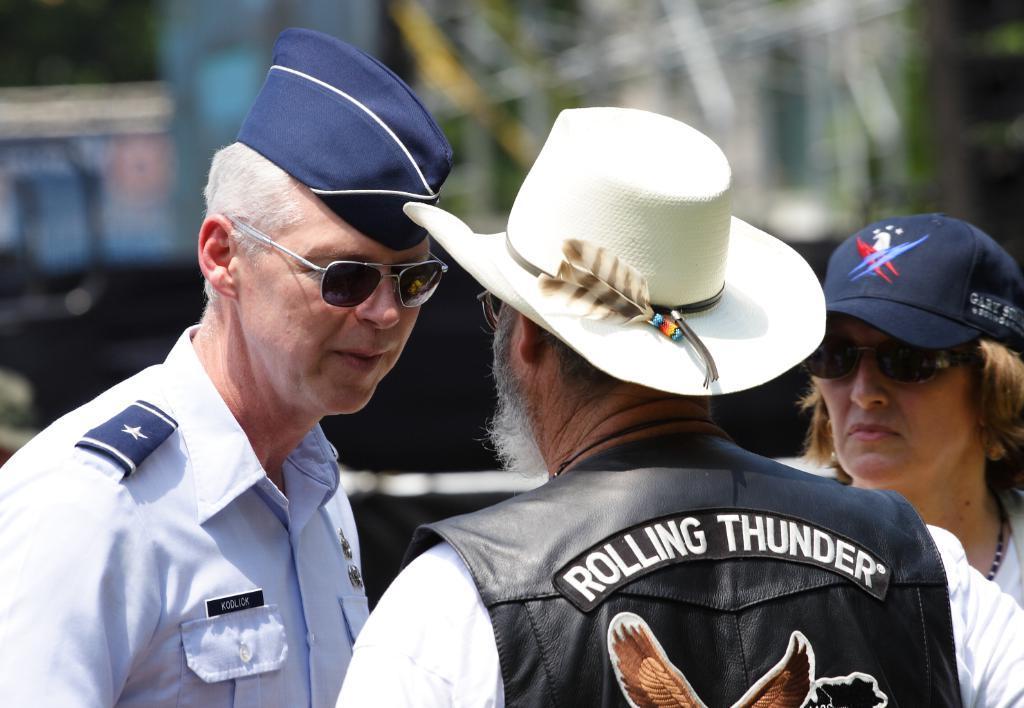Describe this image in one or two sentences. In the image we can see there are two men and a woman wearing clothes, cap and goggles. This is a neck chain and the background is blurred. 